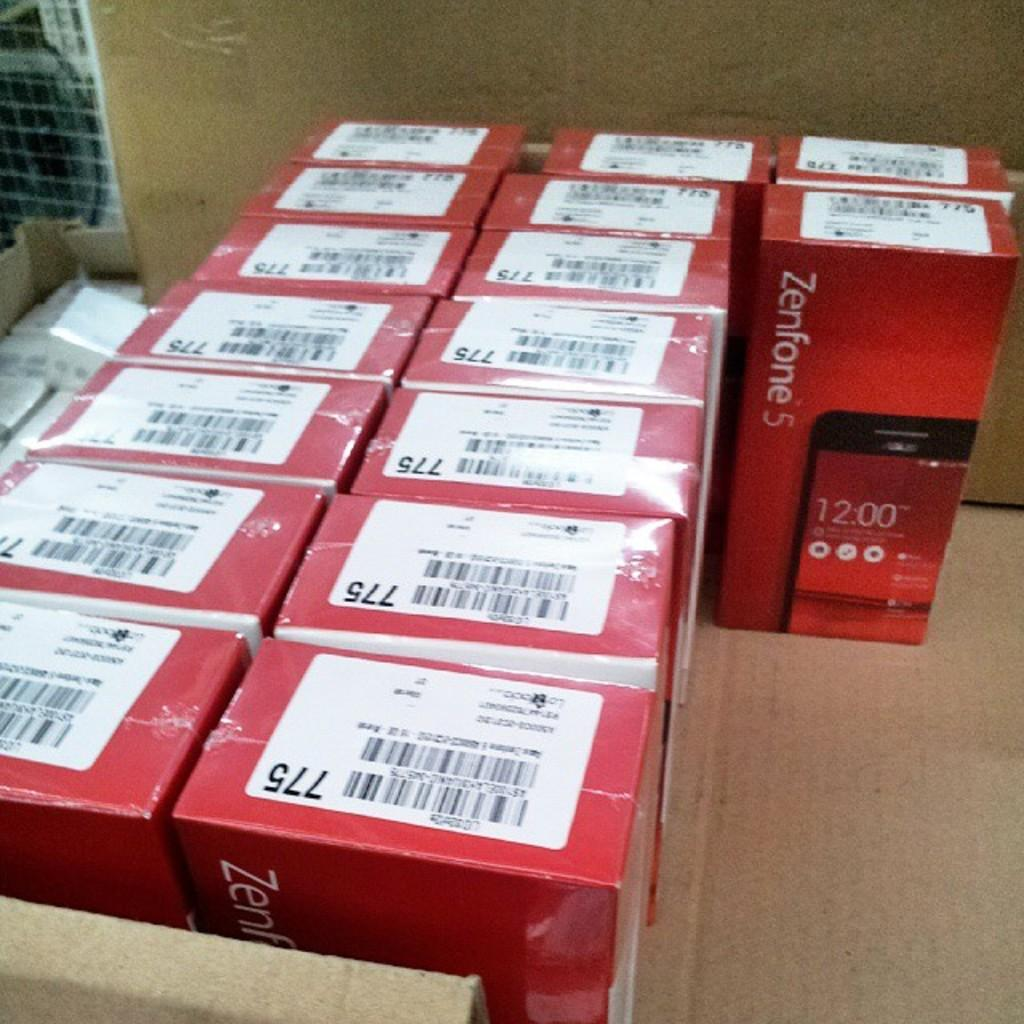<image>
Give a short and clear explanation of the subsequent image. A large case containing several units of the Zenfone 5 in red boxes. 